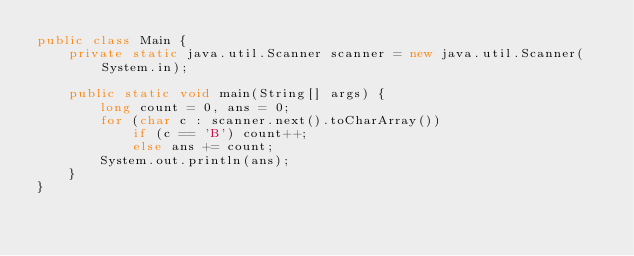Convert code to text. <code><loc_0><loc_0><loc_500><loc_500><_Java_>public class Main {
    private static java.util.Scanner scanner = new java.util.Scanner(System.in);

    public static void main(String[] args) {
        long count = 0, ans = 0;
        for (char c : scanner.next().toCharArray())
            if (c == 'B') count++;
            else ans += count;
        System.out.println(ans);
    }
}</code> 